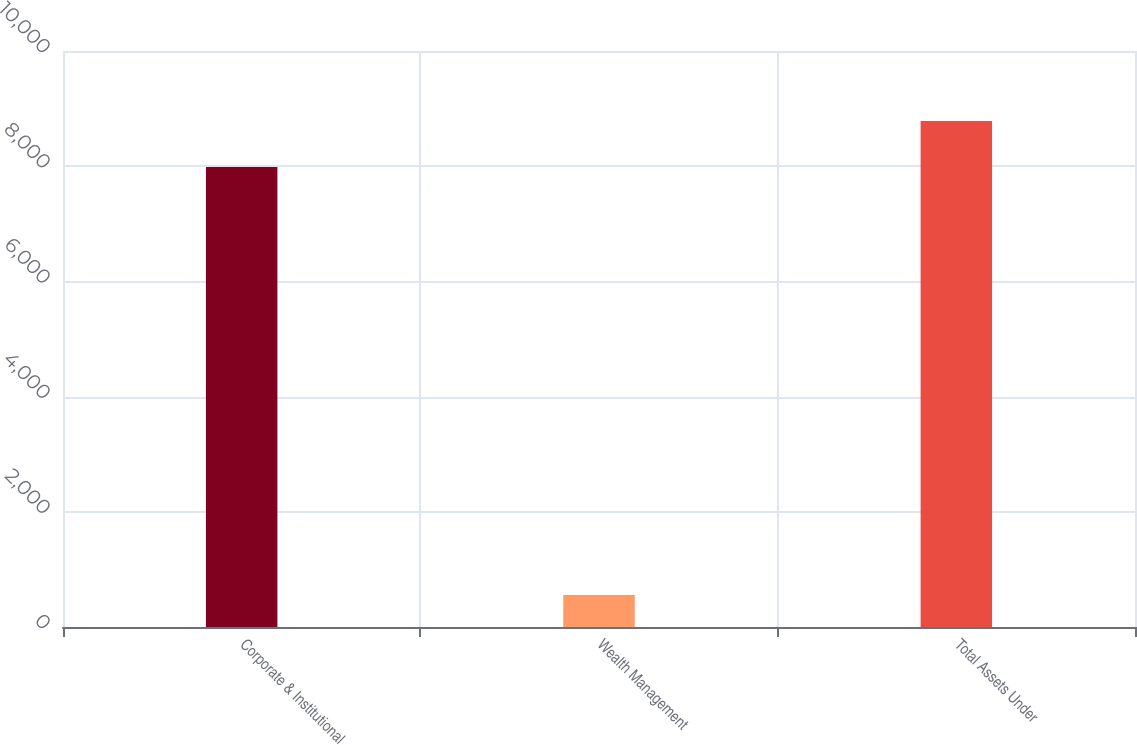Convert chart. <chart><loc_0><loc_0><loc_500><loc_500><bar_chart><fcel>Corporate & Institutional<fcel>Wealth Management<fcel>Total Assets Under<nl><fcel>7987<fcel>554.3<fcel>8785.7<nl></chart> 